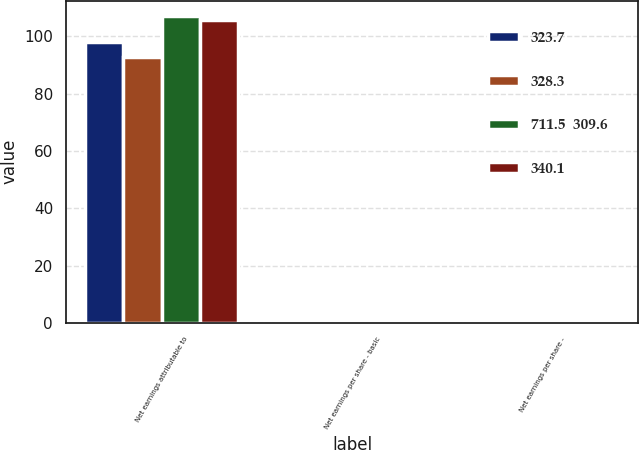<chart> <loc_0><loc_0><loc_500><loc_500><stacked_bar_chart><ecel><fcel>Net earnings attributable to<fcel>Net earnings per share - basic<fcel>Net earnings per share -<nl><fcel>323.7<fcel>98<fcel>0.92<fcel>0.91<nl><fcel>328.3<fcel>92.7<fcel>0.89<fcel>0.88<nl><fcel>711.5  309.6<fcel>107.1<fcel>1.03<fcel>1.02<nl><fcel>340.1<fcel>105.9<fcel>1.04<fcel>1.02<nl></chart> 